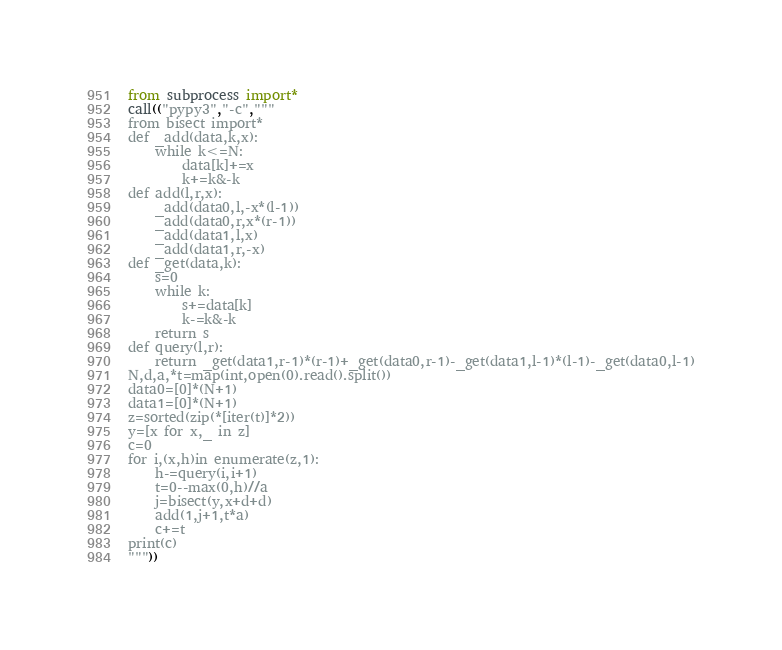<code> <loc_0><loc_0><loc_500><loc_500><_Python_>from subprocess import*
call(("pypy3","-c","""
from bisect import*
def _add(data,k,x):
    while k<=N:
        data[k]+=x
        k+=k&-k
def add(l,r,x):
    _add(data0,l,-x*(l-1))
    _add(data0,r,x*(r-1))
    _add(data1,l,x)
    _add(data1,r,-x)
def _get(data,k):
    s=0
    while k:
        s+=data[k]
        k-=k&-k
    return s
def query(l,r):
    return _get(data1,r-1)*(r-1)+_get(data0,r-1)-_get(data1,l-1)*(l-1)-_get(data0,l-1)
N,d,a,*t=map(int,open(0).read().split())
data0=[0]*(N+1)
data1=[0]*(N+1)
z=sorted(zip(*[iter(t)]*2))
y=[x for x,_ in z]
c=0
for i,(x,h)in enumerate(z,1):
    h-=query(i,i+1)
    t=0--max(0,h)//a
    j=bisect(y,x+d+d)
    add(1,j+1,t*a)
    c+=t
print(c)
"""))</code> 